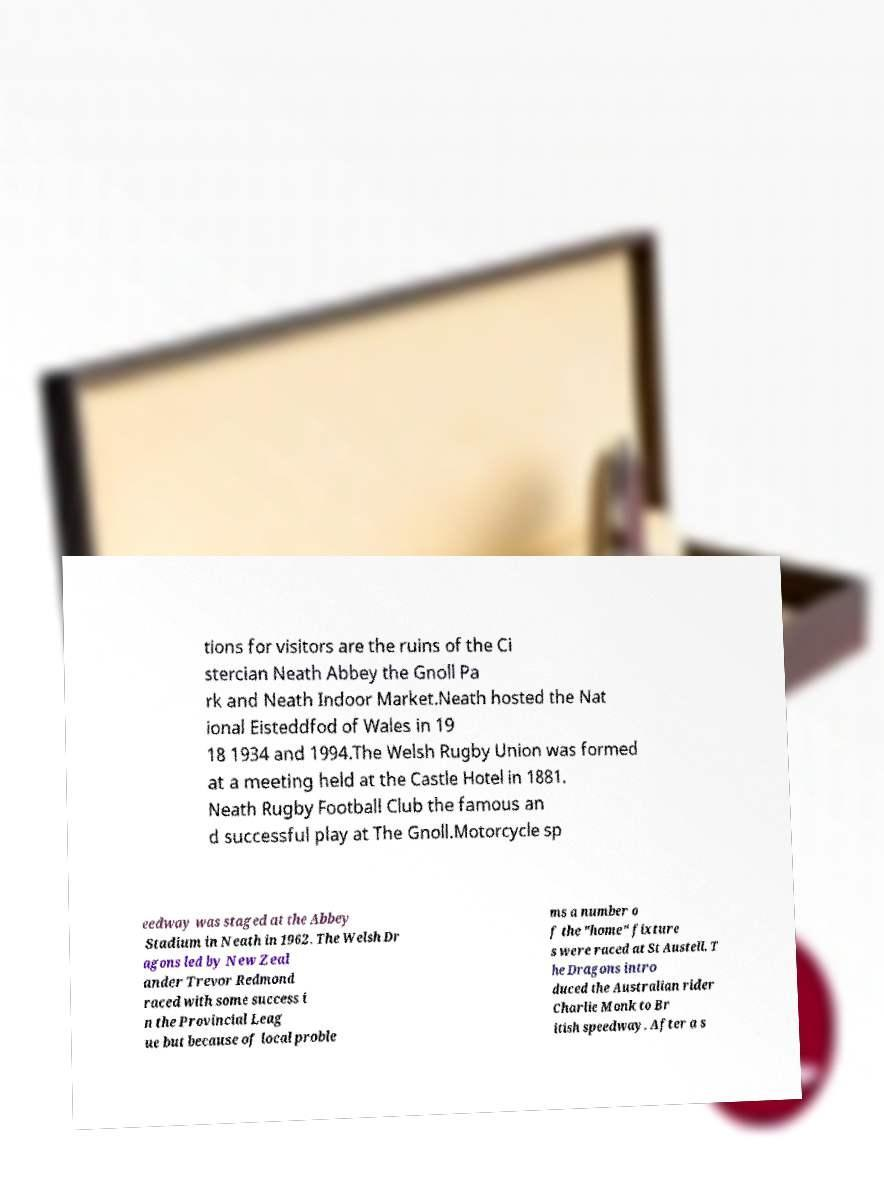Please read and relay the text visible in this image. What does it say? tions for visitors are the ruins of the Ci stercian Neath Abbey the Gnoll Pa rk and Neath Indoor Market.Neath hosted the Nat ional Eisteddfod of Wales in 19 18 1934 and 1994.The Welsh Rugby Union was formed at a meeting held at the Castle Hotel in 1881. Neath Rugby Football Club the famous an d successful play at The Gnoll.Motorcycle sp eedway was staged at the Abbey Stadium in Neath in 1962. The Welsh Dr agons led by New Zeal ander Trevor Redmond raced with some success i n the Provincial Leag ue but because of local proble ms a number o f the "home" fixture s were raced at St Austell. T he Dragons intro duced the Australian rider Charlie Monk to Br itish speedway. After a s 